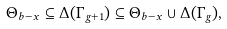Convert formula to latex. <formula><loc_0><loc_0><loc_500><loc_500>\Theta _ { b - x } \subseteq \Delta ( \Gamma _ { g + 1 } ) \subseteq \Theta _ { b - x } \cup \Delta ( \Gamma _ { g } ) ,</formula> 